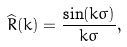<formula> <loc_0><loc_0><loc_500><loc_500>\widehat { R } ( k ) = \frac { \sin ( k \sigma ) } { k \sigma } ,</formula> 